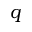Convert formula to latex. <formula><loc_0><loc_0><loc_500><loc_500>q</formula> 